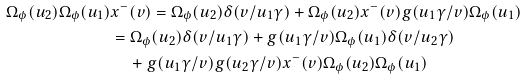<formula> <loc_0><loc_0><loc_500><loc_500>\Omega _ { \phi } ( u _ { 2 } ) \Omega _ { \phi } ( u _ { 1 } ) & x ^ { - } ( v ) = \Omega _ { \phi } ( u _ { 2 } ) \delta ( v / u _ { 1 } \gamma ) + \Omega _ { \phi } ( u _ { 2 } ) x ^ { - } ( v ) g ( u _ { 1 } \gamma / v ) \Omega _ { \phi } ( u _ { 1 } ) \\ & = \Omega _ { \phi } ( u _ { 2 } ) \delta ( v / u _ { 1 } \gamma ) + g ( u _ { 1 } \gamma / v ) \Omega _ { \phi } ( u _ { 1 } ) \delta ( v / u _ { 2 } \gamma ) \\ & \quad + g ( u _ { 1 } \gamma / v ) g ( u _ { 2 } \gamma / v ) x ^ { - } ( v ) \Omega _ { \phi } ( u _ { 2 } ) \Omega _ { \phi } ( u _ { 1 } )</formula> 